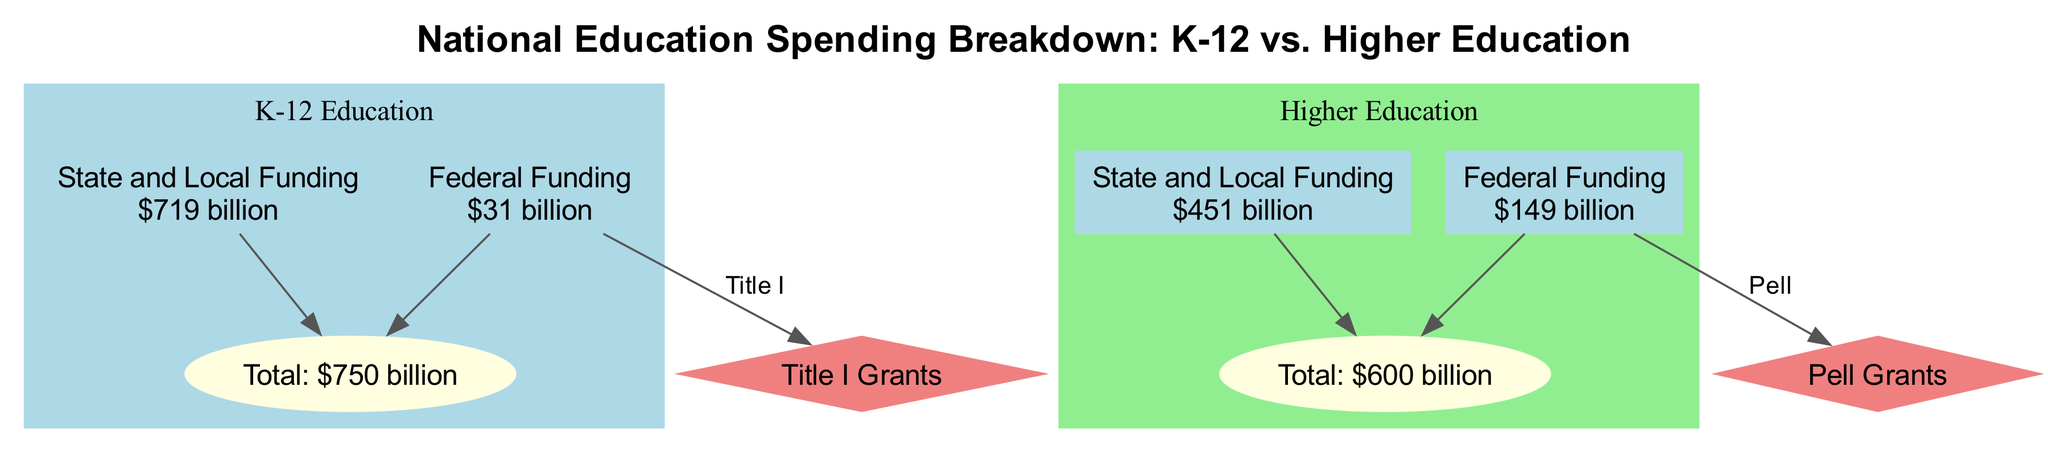What is the total spending on K-12 education? The diagram indicates that the total spending on K-12 education is represented with the label "Total: $750 billion." This information can be found within the "K-12" node, specifically the "K-12_Total" label.
Answer: $750 billion How much federal funding is allocated to higher education? The diagram shows that the federal funding for higher education is labeled as "$149 billion" under the "Higher Ed Federal" node. This represents the sum of federal contributions to higher education.
Answer: $149 billion What proportion of K-12 funding comes from state and local sources? According to the diagram, K-12 funding from state and local sources is labeled as "$719 billion," while the total K-12 funding is $750 billion. To find the proportion, you can divide the state and local funding by the total: $719 billion / $750 billion. This gives insight into the reliance on state and local funding.
Answer: 95.87% Which program is associated with Title I funding? The connection displayed in the diagram shows that Title I Grants, represented as "Program 1," is linked by an edge from the "K-12 Federal Funding" node, indicating that Title I funding falls under the federal allocation for K-12 education.
Answer: Title I Grants What is the combined federal and state/local funding for higher education? By looking at the respective nodes for higher education, federal funding is $149 billion and state/local funding is $451 billion. Adding these two values together: $149 billion + $451 billion results in the total funding for higher education. This involves aggregating both forms of contributions.
Answer: $600 billion How many total nodes are present in the diagram? The total number of nodes is counted by tallying each unique node listed in the diagram, which includes K-12 education nodes, higher education nodes, and the specific programs linked to their respective funding sources. Counting all nodes in the diagram gives the answer.
Answer: 10 